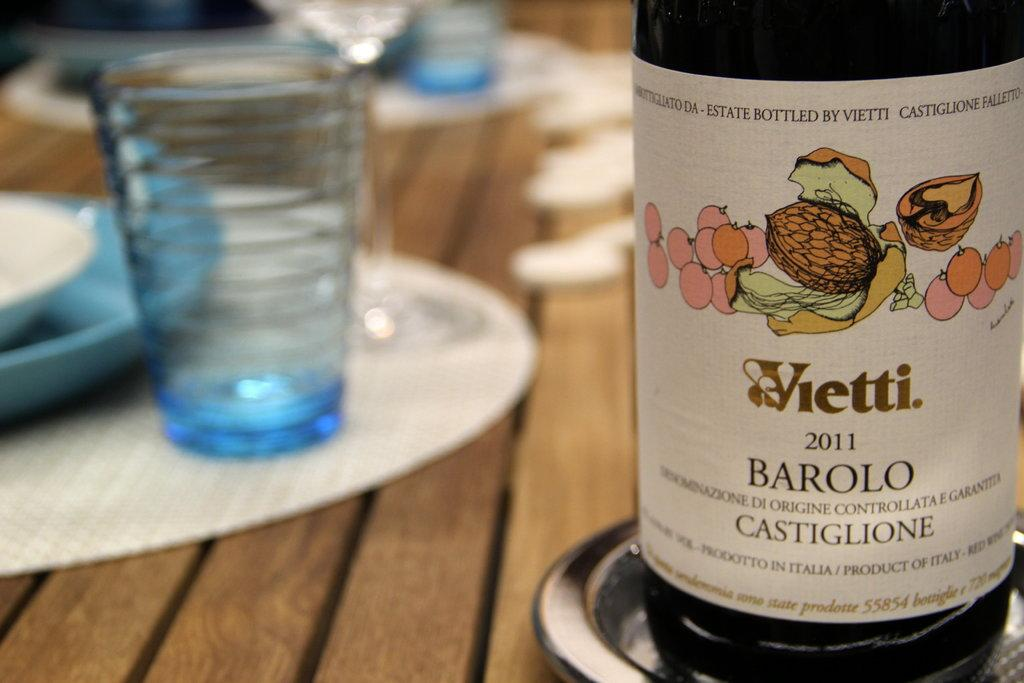What type of container is visible in the image? There is a bottle in the image. What other type of container can be seen in the image? There is a glass in the image. What else is present in the image besides the containers? There are plates in the image. How does the deer interact with the bottle in the image? There is no deer present in the image, so it cannot interact with the bottle. 